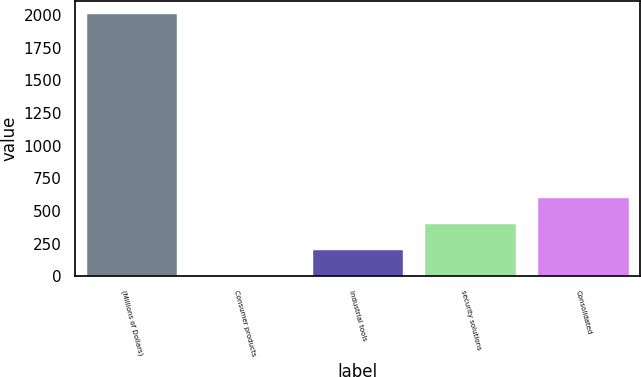<chart> <loc_0><loc_0><loc_500><loc_500><bar_chart><fcel>(Millions of Dollars)<fcel>Consumer products<fcel>Industrial tools<fcel>security solutions<fcel>Consolidated<nl><fcel>2006<fcel>3.2<fcel>203.48<fcel>403.76<fcel>604.04<nl></chart> 